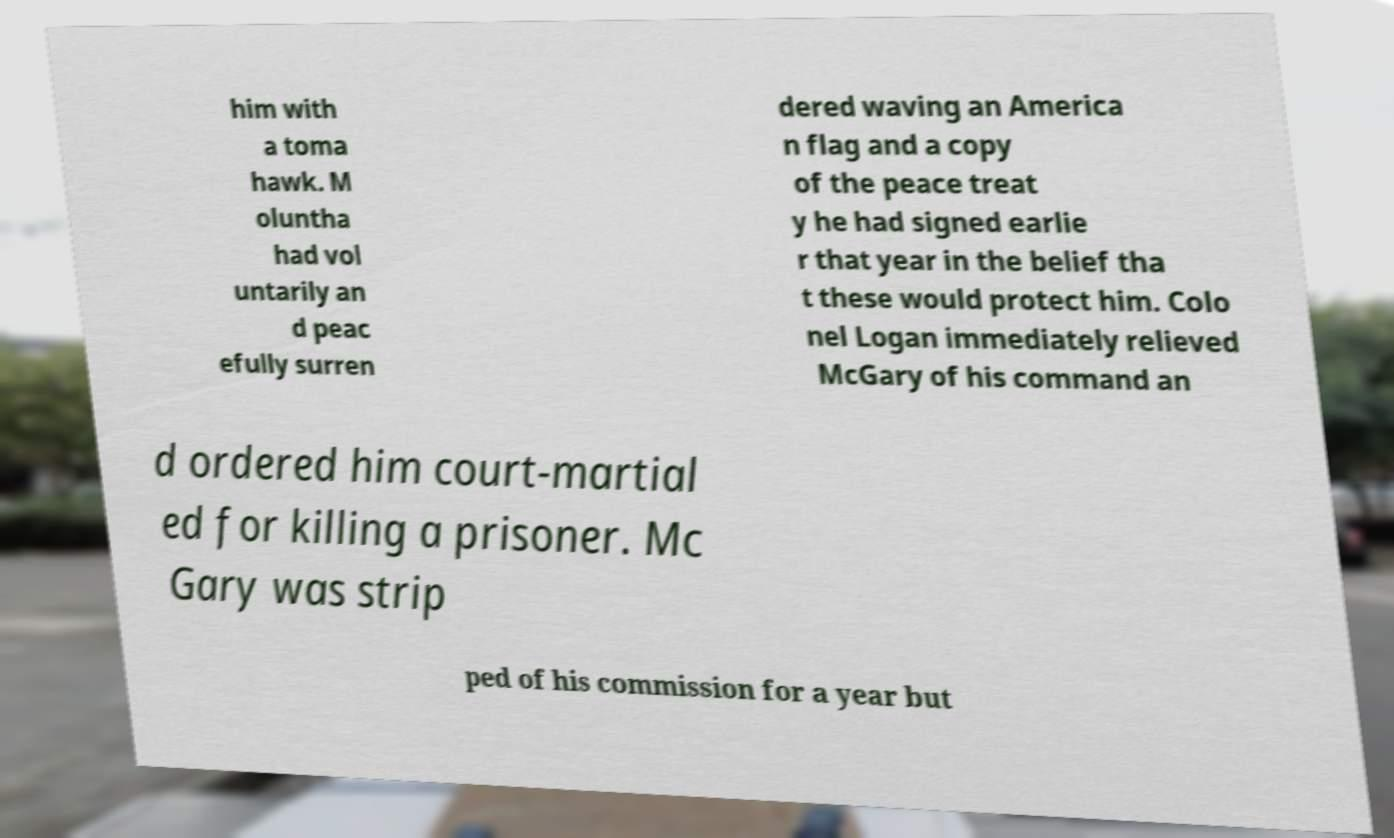Can you read and provide the text displayed in the image?This photo seems to have some interesting text. Can you extract and type it out for me? him with a toma hawk. M oluntha had vol untarily an d peac efully surren dered waving an America n flag and a copy of the peace treat y he had signed earlie r that year in the belief tha t these would protect him. Colo nel Logan immediately relieved McGary of his command an d ordered him court-martial ed for killing a prisoner. Mc Gary was strip ped of his commission for a year but 